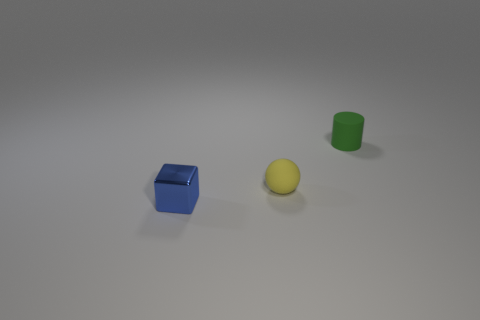Add 1 small spheres. How many objects exist? 4 Subtract all spheres. How many objects are left? 2 Add 2 rubber cylinders. How many rubber cylinders are left? 3 Add 2 yellow metallic objects. How many yellow metallic objects exist? 2 Subtract 0 red balls. How many objects are left? 3 Subtract all small metal blocks. Subtract all tiny yellow matte spheres. How many objects are left? 1 